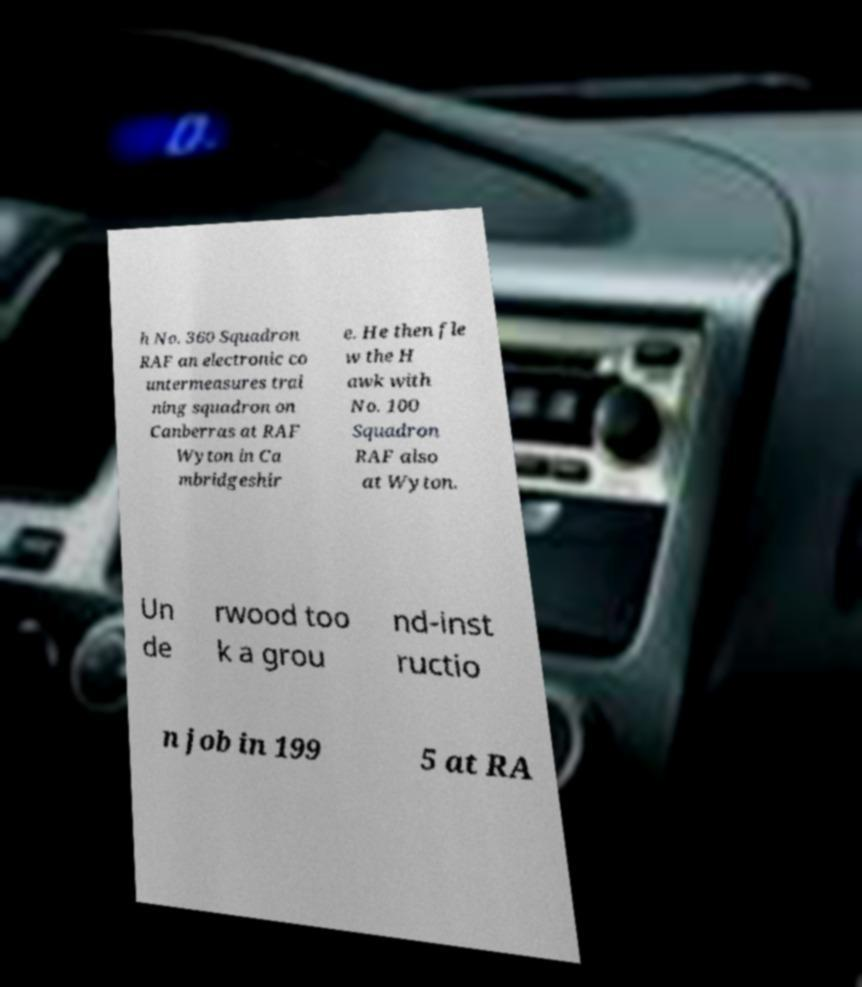Could you extract and type out the text from this image? h No. 360 Squadron RAF an electronic co untermeasures trai ning squadron on Canberras at RAF Wyton in Ca mbridgeshir e. He then fle w the H awk with No. 100 Squadron RAF also at Wyton. Un de rwood too k a grou nd-inst ructio n job in 199 5 at RA 